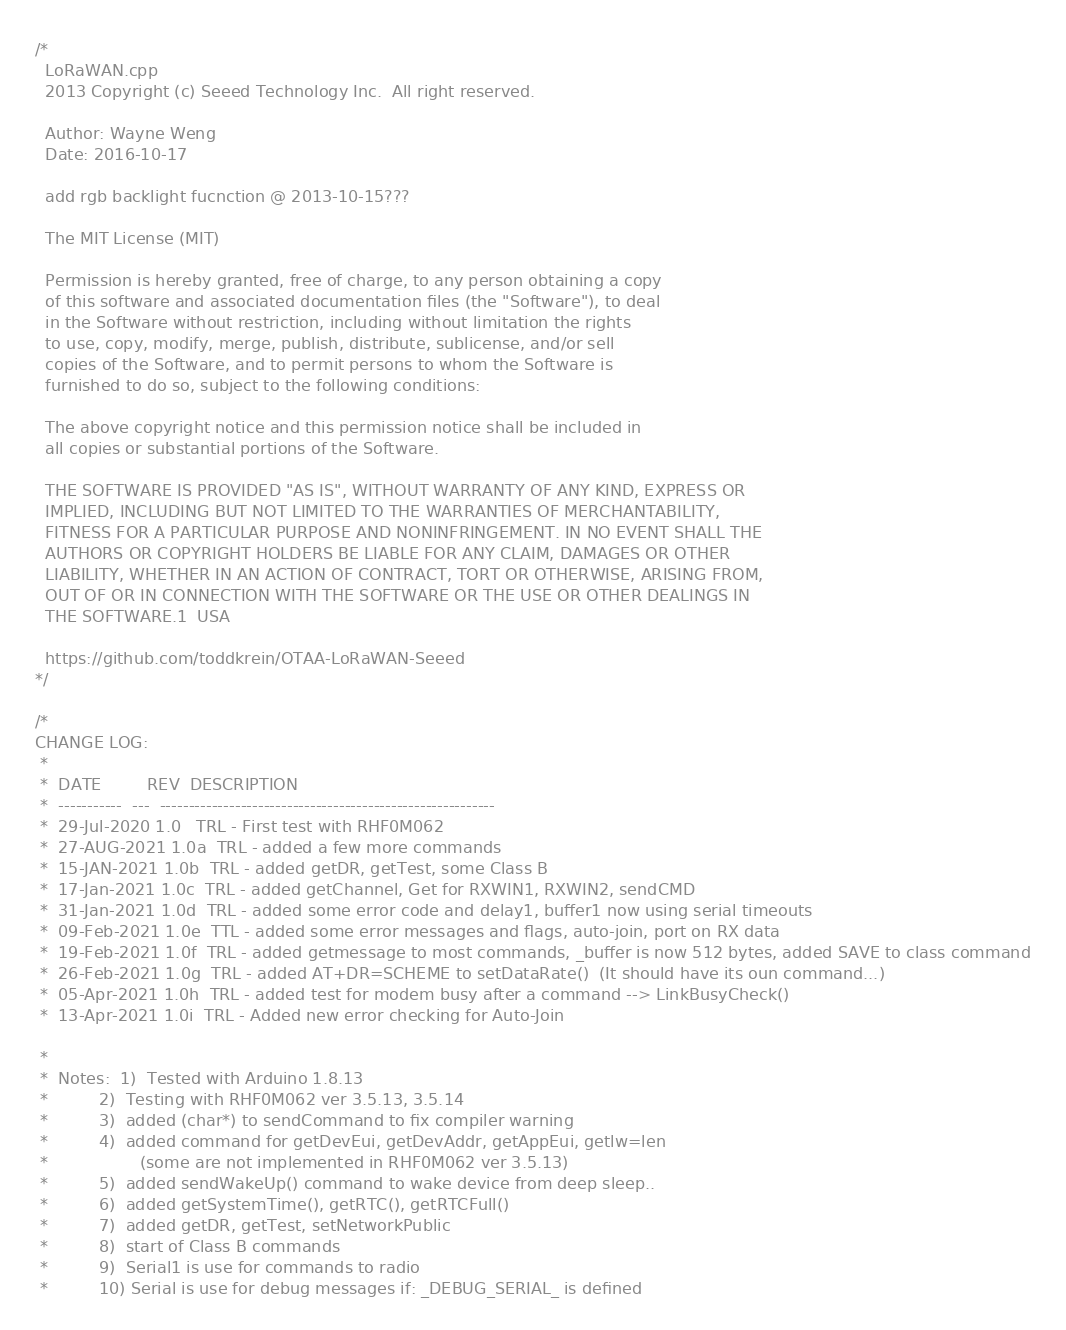Convert code to text. <code><loc_0><loc_0><loc_500><loc_500><_C++_>/*
  LoRaWAN.cpp
  2013 Copyright (c) Seeed Technology Inc.  All right reserved.

  Author: Wayne Weng
  Date: 2016-10-17

  add rgb backlight fucnction @ 2013-10-15???
  
  The MIT License (MIT)

  Permission is hereby granted, free of charge, to any person obtaining a copy
  of this software and associated documentation files (the "Software"), to deal
  in the Software without restriction, including without limitation the rights
  to use, copy, modify, merge, publish, distribute, sublicense, and/or sell
  copies of the Software, and to permit persons to whom the Software is
  furnished to do so, subject to the following conditions:

  The above copyright notice and this permission notice shall be included in
  all copies or substantial portions of the Software.

  THE SOFTWARE IS PROVIDED "AS IS", WITHOUT WARRANTY OF ANY KIND, EXPRESS OR
  IMPLIED, INCLUDING BUT NOT LIMITED TO THE WARRANTIES OF MERCHANTABILITY,
  FITNESS FOR A PARTICULAR PURPOSE AND NONINFRINGEMENT. IN NO EVENT SHALL THE
  AUTHORS OR COPYRIGHT HOLDERS BE LIABLE FOR ANY CLAIM, DAMAGES OR OTHER
  LIABILITY, WHETHER IN AN ACTION OF CONTRACT, TORT OR OTHERWISE, ARISING FROM,
  OUT OF OR IN CONNECTION WITH THE SOFTWARE OR THE USE OR OTHER DEALINGS IN
  THE SOFTWARE.1  USA
 
  https://github.com/toddkrein/OTAA-LoRaWAN-Seeed
*/

/*
CHANGE LOG:
 *
 *  DATE         REV  DESCRIPTION
 *  -----------  ---  ----------------------------------------------------------
 *  29-Jul-2020 1.0   TRL - First test with RHF0M062
 *  27-AUG-2021 1.0a  TRL - added a few more commands
 *  15-JAN-2021 1.0b  TRL - added getDR, getTest, some Class B
 *  17-Jan-2021 1.0c  TRL - added getChannel, Get for RXWIN1, RXWIN2, sendCMD
 *  31-Jan-2021 1.0d  TRL - added some error code and delay1, buffer1 now using serial timeouts
 *  09-Feb-2021 1.0e  TTL - added some error messages and flags, auto-join, port on RX data
 *  19-Feb-2021 1.0f  TRL - added getmessage to most commands, _buffer is now 512 bytes, added SAVE to class command
 *  26-Feb-2021 1.0g  TRL - added AT+DR=SCHEME to setDataRate()  (It should have its oun command...)
 *  05-Apr-2021 1.0h  TRL - added test for modem busy after a command --> LinkBusyCheck()
 *  13-Apr-2021 1.0i  TRL - Added new error checking for Auto-Join
 
 *
 *  Notes:  1)  Tested with Arduino 1.8.13
 *          2)  Testing with RHF0M062 ver 3.5.13, 3.5.14 
 *          3)  added (char*) to sendCommand to fix compiler warning
 *          4)  added command for getDevEui, getDevAddr, getAppEui, getlw=len 
 *                  (some are not implemented in RHF0M062 ver 3.5.13)
 *          5)  added sendWakeUp() command to wake device from deep sleep..
 *          6)  added getSystemTime(), getRTC(), getRTCFull()
 *          7)  added getDR, getTest, setNetworkPublic
 *          8)  start of Class B commands
 *          9)  Serial1 is use for commands to radio
 *          10) Serial is use for debug messages if: _DEBUG_SERIAL_ is defined</code> 